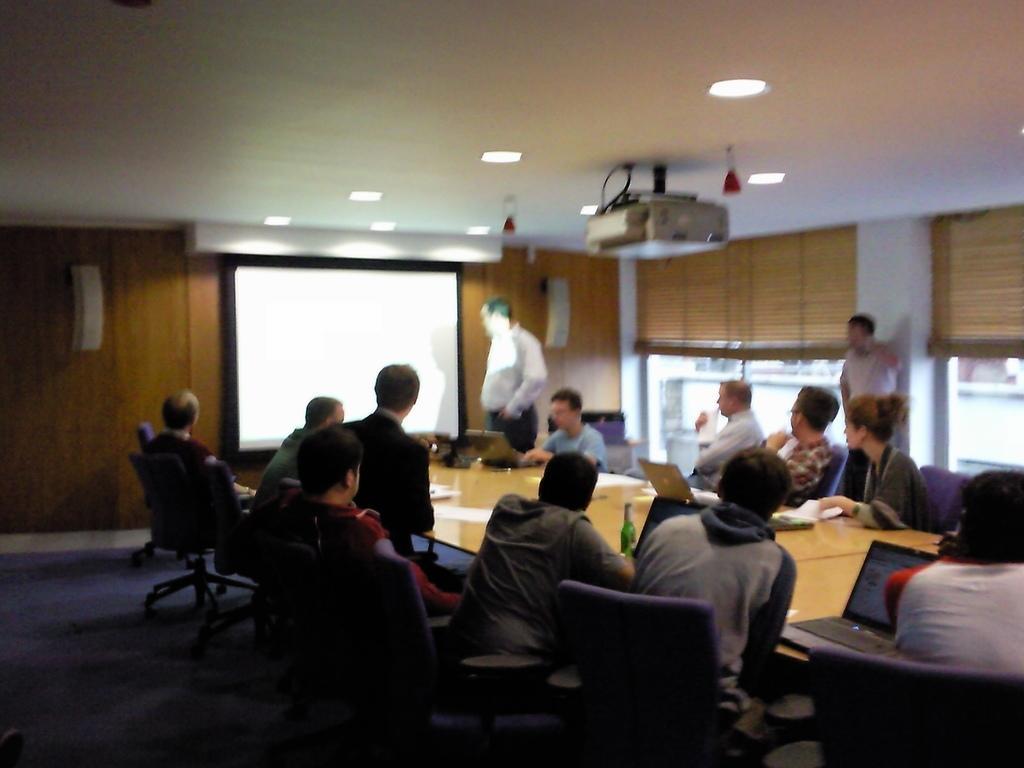Describe this image in one or two sentences. In this image, There is a table which is in yellow color on that there are some laptops in black color, There are some people sitting on the chairs around the table, In the background there is a wall which is in brown color on that wall there is a white color power point projection, In the top there is a white color roof. 